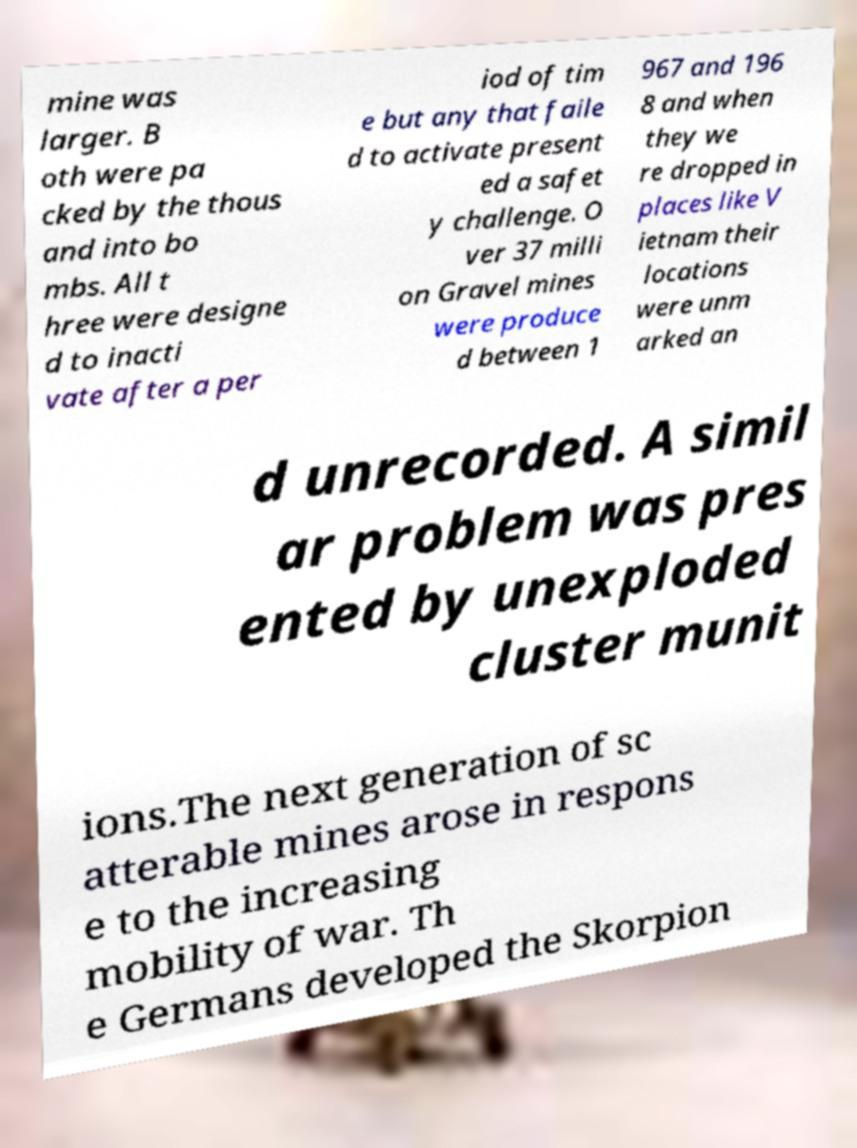Please identify and transcribe the text found in this image. mine was larger. B oth were pa cked by the thous and into bo mbs. All t hree were designe d to inacti vate after a per iod of tim e but any that faile d to activate present ed a safet y challenge. O ver 37 milli on Gravel mines were produce d between 1 967 and 196 8 and when they we re dropped in places like V ietnam their locations were unm arked an d unrecorded. A simil ar problem was pres ented by unexploded cluster munit ions.The next generation of sc atterable mines arose in respons e to the increasing mobility of war. Th e Germans developed the Skorpion 